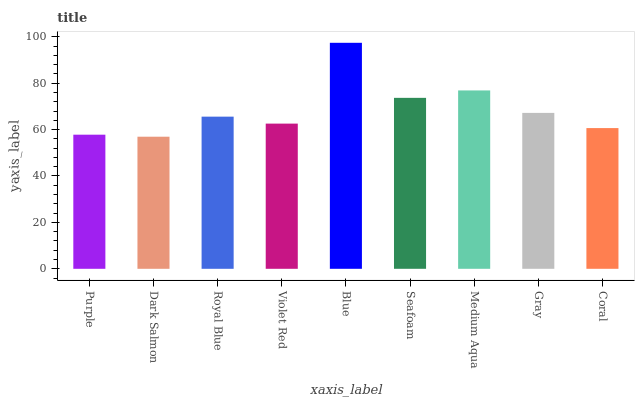Is Dark Salmon the minimum?
Answer yes or no. Yes. Is Blue the maximum?
Answer yes or no. Yes. Is Royal Blue the minimum?
Answer yes or no. No. Is Royal Blue the maximum?
Answer yes or no. No. Is Royal Blue greater than Dark Salmon?
Answer yes or no. Yes. Is Dark Salmon less than Royal Blue?
Answer yes or no. Yes. Is Dark Salmon greater than Royal Blue?
Answer yes or no. No. Is Royal Blue less than Dark Salmon?
Answer yes or no. No. Is Royal Blue the high median?
Answer yes or no. Yes. Is Royal Blue the low median?
Answer yes or no. Yes. Is Violet Red the high median?
Answer yes or no. No. Is Medium Aqua the low median?
Answer yes or no. No. 